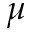<formula> <loc_0><loc_0><loc_500><loc_500>\mu</formula> 